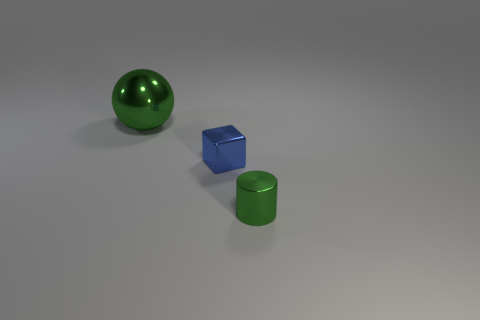Add 1 large gray metallic spheres. How many objects exist? 4 Subtract all spheres. How many objects are left? 2 Subtract all gray rubber balls. Subtract all metallic things. How many objects are left? 0 Add 3 blue blocks. How many blue blocks are left? 4 Add 2 tiny matte blocks. How many tiny matte blocks exist? 2 Subtract 0 cyan cylinders. How many objects are left? 3 